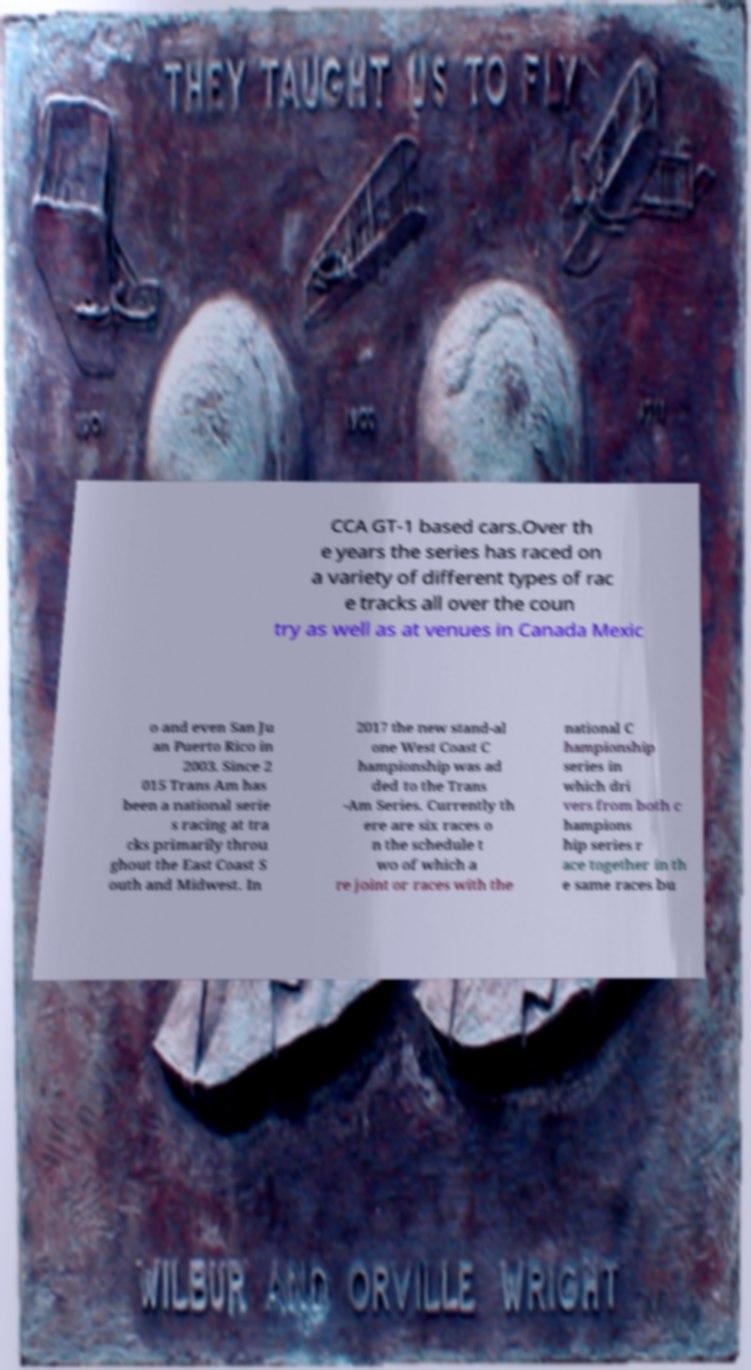There's text embedded in this image that I need extracted. Can you transcribe it verbatim? CCA GT-1 based cars.Over th e years the series has raced on a variety of different types of rac e tracks all over the coun try as well as at venues in Canada Mexic o and even San Ju an Puerto Rico in 2003. Since 2 015 Trans Am has been a national serie s racing at tra cks primarily throu ghout the East Coast S outh and Midwest. In 2017 the new stand-al one West Coast C hampionship was ad ded to the Trans -Am Series. Currently th ere are six races o n the schedule t wo of which a re joint or races with the national C hampionship series in which dri vers from both c hampions hip series r ace together in th e same races bu 